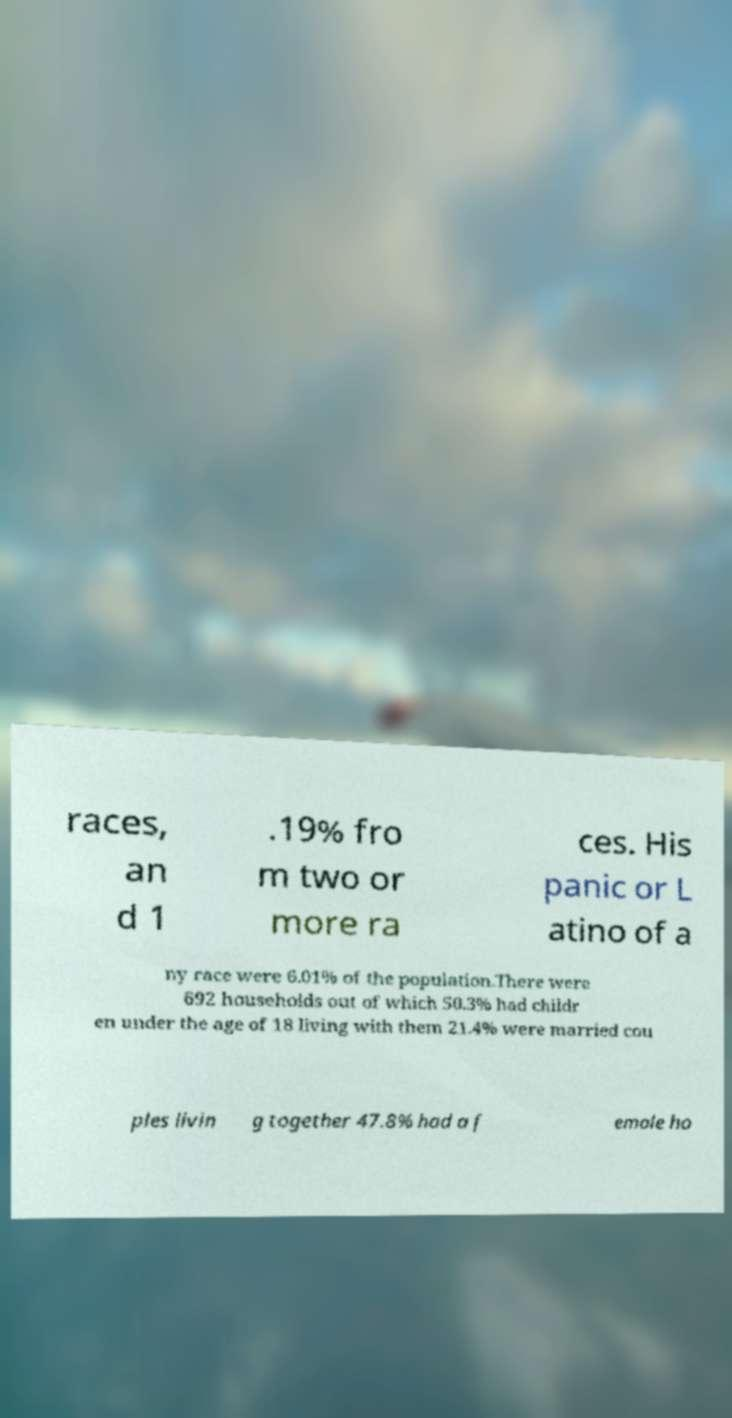Can you read and provide the text displayed in the image?This photo seems to have some interesting text. Can you extract and type it out for me? races, an d 1 .19% fro m two or more ra ces. His panic or L atino of a ny race were 6.01% of the population.There were 692 households out of which 50.3% had childr en under the age of 18 living with them 21.4% were married cou ples livin g together 47.8% had a f emale ho 